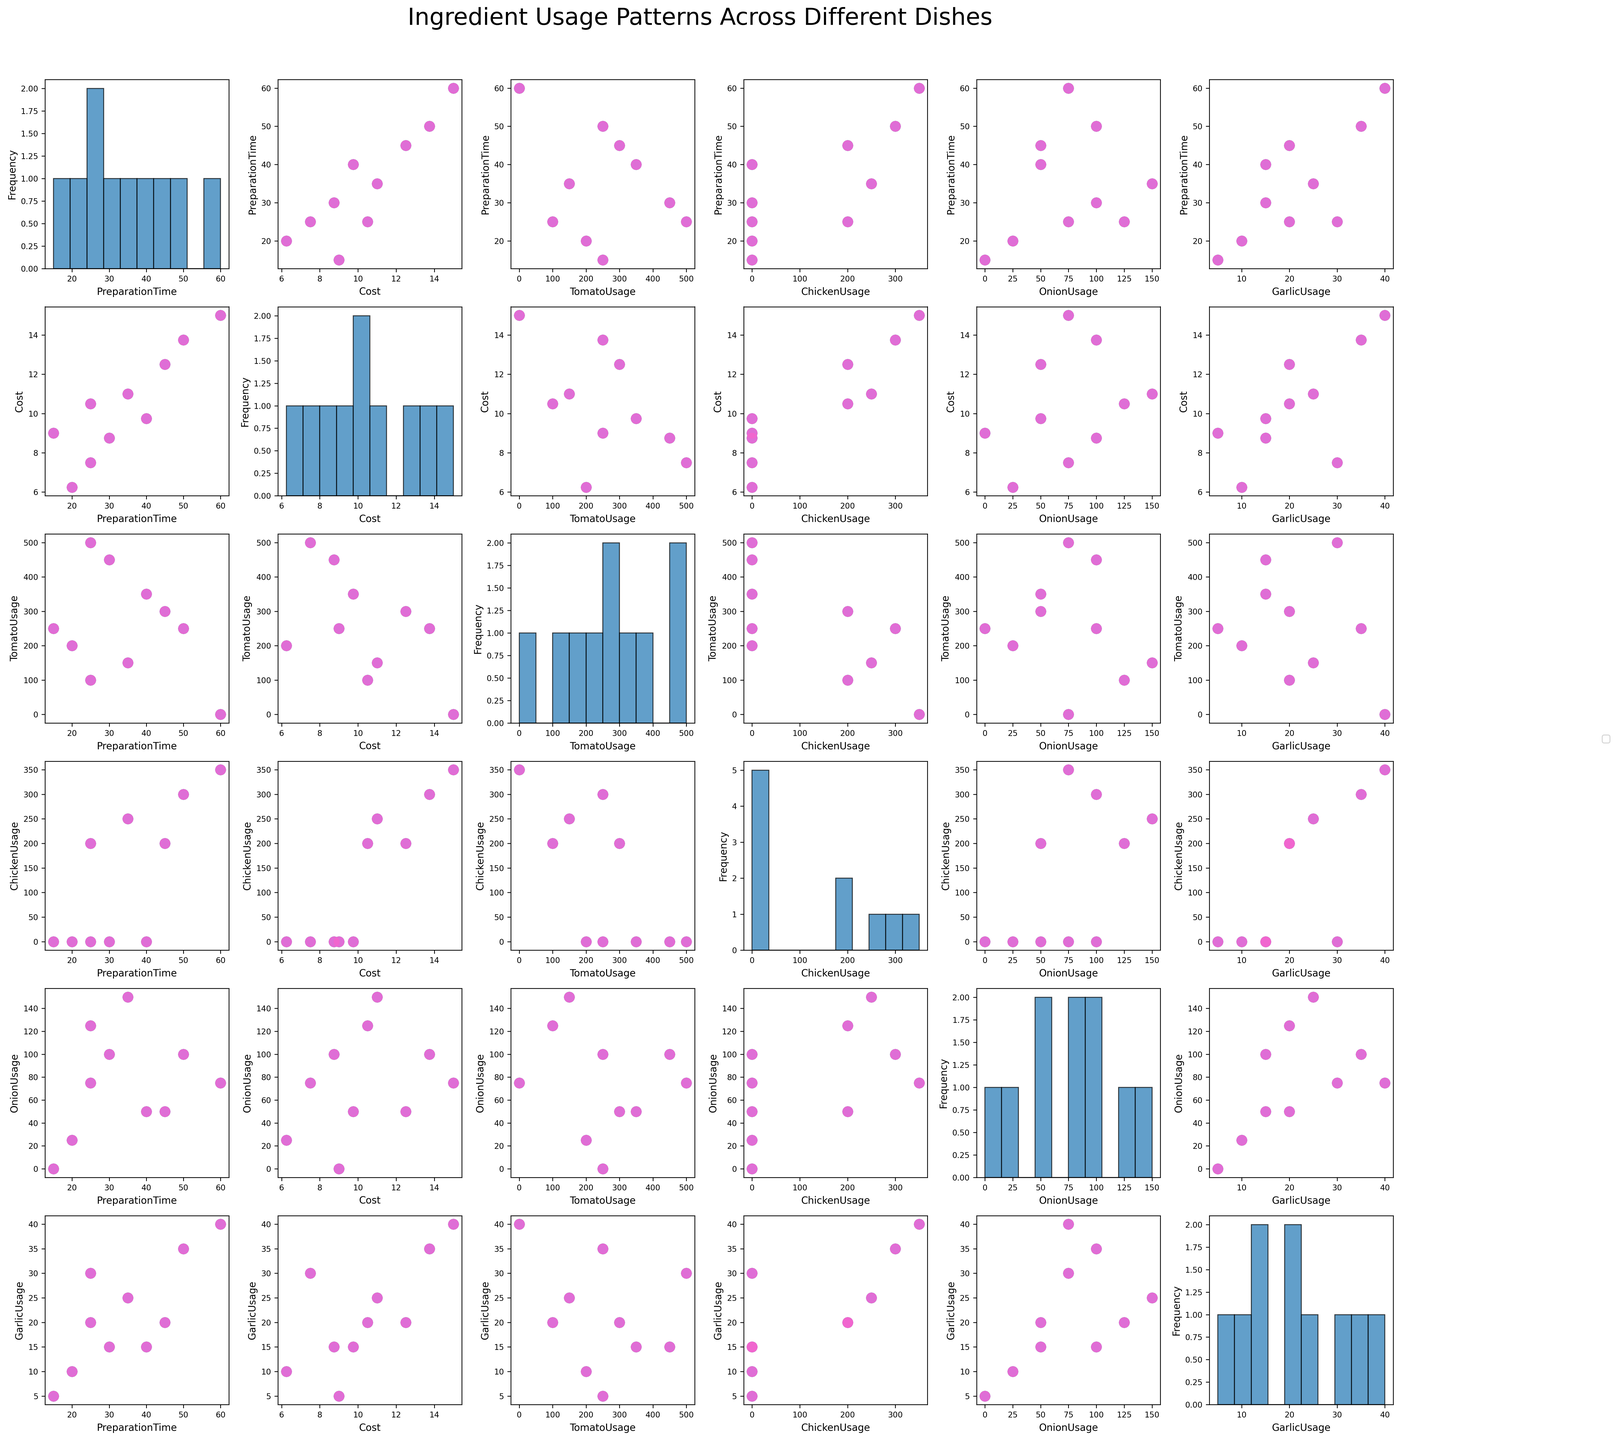What does the title of the scatterplot matrix indicate? The title is located at the top center of the plot and reads "Ingredient Usage Patterns Across Different Dishes," indicating that the plot showcases the relationship between different ingredients, preparation times, and costs.
Answer: Ingredient Usage Patterns Across Different Dishes Which dish has the highest cost and its preparation time? By examining the plot where the Cost is on the x-axis and PreparationTime is on the y-axis, we find that "Garlic Roasted Chicken" is positioned at the highest cost value around $15.00 on the x-axis with a corresponding PreparationTime of 60 minutes.
Answer: Garlic Roasted Chicken, 60 minutes How does the TomatoUsage correlate with the Cost? Observing the scatterplots involving TomatoUsage and Cost, we look for the overall trend shown by the data points. There is no single straightforward positive or negative correlation; dishes with high TomatoUsage have varying costs, which indicates a weak or no correlation.
Answer: Weak correlation Which dish has the highest GarlicUsage and what is its OnionUsage? Looking at the scatter rows and columns involving GarlicUsage, the point with the highest GarlicUsage (around 40 units) corresponds to "Garlic Roasted Chicken", and for the same point in OnionUsage, we see it has around 75 units.
Answer: Garlic Roasted Chicken, 75 units What’s the average Preparation Time among all dishes? To calculate the average, sum all PreparationTime values from the dishes: (45 + 30 + 60 + 20 + 35 + 25 + 50 + 15 + 25 + 40 = 345). Divide the sum by the number of dishes (10) to get (345 / 10).
Answer: 34.5 minutes Which ingredient usage varies most widely across the dishes? By comparing the range of histograms in the diagonal plots, TomatoUsage has the widest range, spanning from 0 to 500 units, indicating the greatest variability.
Answer: TomatoUsage How many dishes use Chicken as an ingredient? Look at the scatter plots involving ChickenUsage and count the distinct label colors where ChickenUsage is greater than zero. There are 5 dishes: Chicken Parmesan, Garlic Roasted Chicken, Chicken Fajitas, Chicken Cacciatore, and Chicken Stir Fry.
Answer: 5 dishes Is there a visual relationship between PreparationTime and OnionUsage? Checking the scatter plot with PreparationTime on the y-axis and OnionUsage on the x-axis, we notice a general trend that as OnionUsage increases, PreparationTimes also tend to be higher, suggesting a positive relationship.
Answer: Positive relationship What's the highest Cost among the dishes without any TomatoUsage and the associated GarlicUsage? Find the points in the scatterplots where TomatoUsage is zero and identify the highest Cost: Garlic Roasted Chicken with a cost of $15.00 and a GarlicUsage of 40 units.
Answer: $15.00, 40 units 